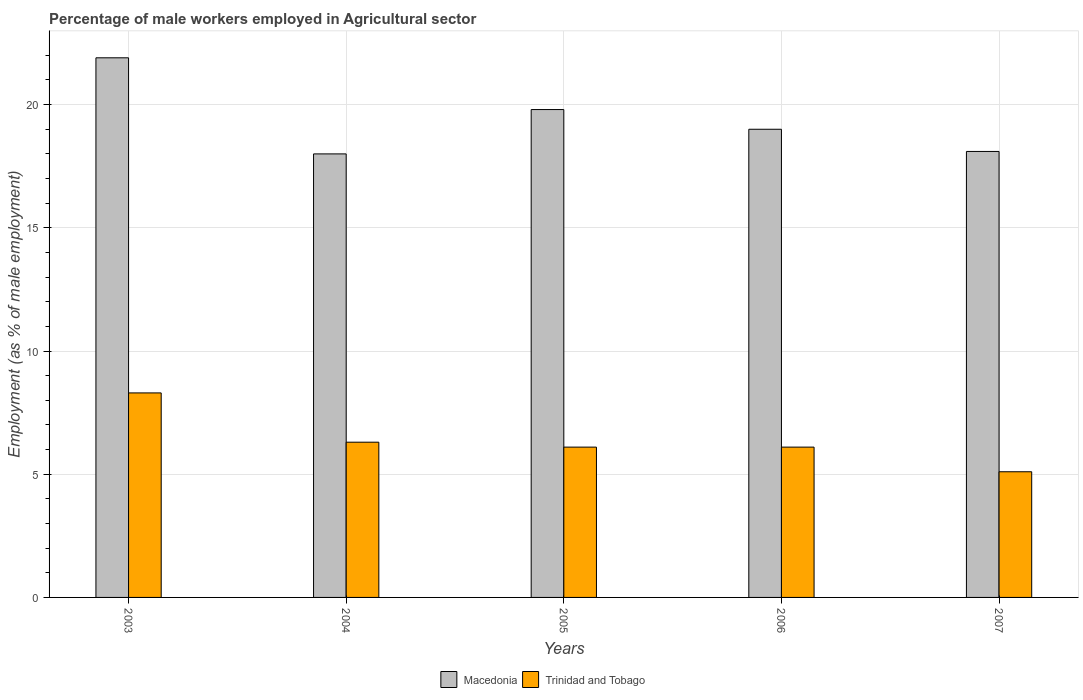How many groups of bars are there?
Your response must be concise. 5. Are the number of bars on each tick of the X-axis equal?
Your answer should be very brief. Yes. In how many cases, is the number of bars for a given year not equal to the number of legend labels?
Offer a very short reply. 0. What is the percentage of male workers employed in Agricultural sector in Macedonia in 2005?
Provide a short and direct response. 19.8. Across all years, what is the maximum percentage of male workers employed in Agricultural sector in Trinidad and Tobago?
Give a very brief answer. 8.3. Across all years, what is the minimum percentage of male workers employed in Agricultural sector in Trinidad and Tobago?
Provide a short and direct response. 5.1. In which year was the percentage of male workers employed in Agricultural sector in Macedonia maximum?
Your response must be concise. 2003. What is the total percentage of male workers employed in Agricultural sector in Trinidad and Tobago in the graph?
Your response must be concise. 31.9. What is the difference between the percentage of male workers employed in Agricultural sector in Trinidad and Tobago in 2003 and that in 2006?
Give a very brief answer. 2.2. What is the difference between the percentage of male workers employed in Agricultural sector in Trinidad and Tobago in 2005 and the percentage of male workers employed in Agricultural sector in Macedonia in 2004?
Your answer should be very brief. -11.9. What is the average percentage of male workers employed in Agricultural sector in Trinidad and Tobago per year?
Ensure brevity in your answer.  6.38. In the year 2005, what is the difference between the percentage of male workers employed in Agricultural sector in Macedonia and percentage of male workers employed in Agricultural sector in Trinidad and Tobago?
Provide a short and direct response. 13.7. What is the ratio of the percentage of male workers employed in Agricultural sector in Trinidad and Tobago in 2004 to that in 2007?
Your answer should be very brief. 1.24. What is the difference between the highest and the second highest percentage of male workers employed in Agricultural sector in Trinidad and Tobago?
Provide a succinct answer. 2. What is the difference between the highest and the lowest percentage of male workers employed in Agricultural sector in Macedonia?
Ensure brevity in your answer.  3.9. In how many years, is the percentage of male workers employed in Agricultural sector in Macedonia greater than the average percentage of male workers employed in Agricultural sector in Macedonia taken over all years?
Ensure brevity in your answer.  2. Is the sum of the percentage of male workers employed in Agricultural sector in Macedonia in 2003 and 2005 greater than the maximum percentage of male workers employed in Agricultural sector in Trinidad and Tobago across all years?
Your answer should be compact. Yes. What does the 1st bar from the left in 2006 represents?
Offer a terse response. Macedonia. What does the 2nd bar from the right in 2006 represents?
Give a very brief answer. Macedonia. Are all the bars in the graph horizontal?
Provide a short and direct response. No. What is the difference between two consecutive major ticks on the Y-axis?
Your response must be concise. 5. Are the values on the major ticks of Y-axis written in scientific E-notation?
Offer a terse response. No. Does the graph contain grids?
Offer a very short reply. Yes. What is the title of the graph?
Your answer should be very brief. Percentage of male workers employed in Agricultural sector. What is the label or title of the X-axis?
Your response must be concise. Years. What is the label or title of the Y-axis?
Your answer should be very brief. Employment (as % of male employment). What is the Employment (as % of male employment) in Macedonia in 2003?
Offer a very short reply. 21.9. What is the Employment (as % of male employment) of Trinidad and Tobago in 2003?
Provide a short and direct response. 8.3. What is the Employment (as % of male employment) in Trinidad and Tobago in 2004?
Your answer should be compact. 6.3. What is the Employment (as % of male employment) of Macedonia in 2005?
Offer a terse response. 19.8. What is the Employment (as % of male employment) of Trinidad and Tobago in 2005?
Offer a very short reply. 6.1. What is the Employment (as % of male employment) of Macedonia in 2006?
Ensure brevity in your answer.  19. What is the Employment (as % of male employment) of Trinidad and Tobago in 2006?
Give a very brief answer. 6.1. What is the Employment (as % of male employment) of Macedonia in 2007?
Your answer should be very brief. 18.1. What is the Employment (as % of male employment) in Trinidad and Tobago in 2007?
Offer a very short reply. 5.1. Across all years, what is the maximum Employment (as % of male employment) of Macedonia?
Offer a terse response. 21.9. Across all years, what is the maximum Employment (as % of male employment) in Trinidad and Tobago?
Make the answer very short. 8.3. Across all years, what is the minimum Employment (as % of male employment) of Trinidad and Tobago?
Your answer should be compact. 5.1. What is the total Employment (as % of male employment) in Macedonia in the graph?
Give a very brief answer. 96.8. What is the total Employment (as % of male employment) in Trinidad and Tobago in the graph?
Provide a short and direct response. 31.9. What is the difference between the Employment (as % of male employment) in Macedonia in 2003 and that in 2004?
Ensure brevity in your answer.  3.9. What is the difference between the Employment (as % of male employment) of Trinidad and Tobago in 2003 and that in 2004?
Your answer should be compact. 2. What is the difference between the Employment (as % of male employment) of Trinidad and Tobago in 2003 and that in 2005?
Offer a terse response. 2.2. What is the difference between the Employment (as % of male employment) of Trinidad and Tobago in 2003 and that in 2006?
Your answer should be very brief. 2.2. What is the difference between the Employment (as % of male employment) in Macedonia in 2004 and that in 2006?
Offer a terse response. -1. What is the difference between the Employment (as % of male employment) in Trinidad and Tobago in 2004 and that in 2006?
Provide a succinct answer. 0.2. What is the difference between the Employment (as % of male employment) in Trinidad and Tobago in 2004 and that in 2007?
Offer a very short reply. 1.2. What is the difference between the Employment (as % of male employment) in Trinidad and Tobago in 2005 and that in 2007?
Your answer should be compact. 1. What is the difference between the Employment (as % of male employment) of Macedonia in 2006 and that in 2007?
Ensure brevity in your answer.  0.9. What is the difference between the Employment (as % of male employment) of Trinidad and Tobago in 2006 and that in 2007?
Your answer should be very brief. 1. What is the difference between the Employment (as % of male employment) of Macedonia in 2003 and the Employment (as % of male employment) of Trinidad and Tobago in 2006?
Provide a succinct answer. 15.8. What is the difference between the Employment (as % of male employment) of Macedonia in 2004 and the Employment (as % of male employment) of Trinidad and Tobago in 2007?
Offer a terse response. 12.9. What is the difference between the Employment (as % of male employment) in Macedonia in 2005 and the Employment (as % of male employment) in Trinidad and Tobago in 2006?
Provide a short and direct response. 13.7. What is the difference between the Employment (as % of male employment) in Macedonia in 2005 and the Employment (as % of male employment) in Trinidad and Tobago in 2007?
Ensure brevity in your answer.  14.7. What is the difference between the Employment (as % of male employment) of Macedonia in 2006 and the Employment (as % of male employment) of Trinidad and Tobago in 2007?
Ensure brevity in your answer.  13.9. What is the average Employment (as % of male employment) of Macedonia per year?
Your answer should be very brief. 19.36. What is the average Employment (as % of male employment) of Trinidad and Tobago per year?
Your answer should be very brief. 6.38. In the year 2003, what is the difference between the Employment (as % of male employment) of Macedonia and Employment (as % of male employment) of Trinidad and Tobago?
Ensure brevity in your answer.  13.6. In the year 2004, what is the difference between the Employment (as % of male employment) in Macedonia and Employment (as % of male employment) in Trinidad and Tobago?
Your answer should be compact. 11.7. In the year 2005, what is the difference between the Employment (as % of male employment) in Macedonia and Employment (as % of male employment) in Trinidad and Tobago?
Your answer should be very brief. 13.7. In the year 2006, what is the difference between the Employment (as % of male employment) of Macedonia and Employment (as % of male employment) of Trinidad and Tobago?
Provide a succinct answer. 12.9. What is the ratio of the Employment (as % of male employment) of Macedonia in 2003 to that in 2004?
Offer a terse response. 1.22. What is the ratio of the Employment (as % of male employment) in Trinidad and Tobago in 2003 to that in 2004?
Ensure brevity in your answer.  1.32. What is the ratio of the Employment (as % of male employment) of Macedonia in 2003 to that in 2005?
Offer a terse response. 1.11. What is the ratio of the Employment (as % of male employment) in Trinidad and Tobago in 2003 to that in 2005?
Offer a terse response. 1.36. What is the ratio of the Employment (as % of male employment) in Macedonia in 2003 to that in 2006?
Give a very brief answer. 1.15. What is the ratio of the Employment (as % of male employment) of Trinidad and Tobago in 2003 to that in 2006?
Your answer should be very brief. 1.36. What is the ratio of the Employment (as % of male employment) in Macedonia in 2003 to that in 2007?
Your answer should be compact. 1.21. What is the ratio of the Employment (as % of male employment) of Trinidad and Tobago in 2003 to that in 2007?
Make the answer very short. 1.63. What is the ratio of the Employment (as % of male employment) of Macedonia in 2004 to that in 2005?
Your answer should be very brief. 0.91. What is the ratio of the Employment (as % of male employment) in Trinidad and Tobago in 2004 to that in 2005?
Give a very brief answer. 1.03. What is the ratio of the Employment (as % of male employment) in Macedonia in 2004 to that in 2006?
Your answer should be compact. 0.95. What is the ratio of the Employment (as % of male employment) of Trinidad and Tobago in 2004 to that in 2006?
Ensure brevity in your answer.  1.03. What is the ratio of the Employment (as % of male employment) of Trinidad and Tobago in 2004 to that in 2007?
Provide a succinct answer. 1.24. What is the ratio of the Employment (as % of male employment) in Macedonia in 2005 to that in 2006?
Provide a succinct answer. 1.04. What is the ratio of the Employment (as % of male employment) of Macedonia in 2005 to that in 2007?
Your response must be concise. 1.09. What is the ratio of the Employment (as % of male employment) in Trinidad and Tobago in 2005 to that in 2007?
Your answer should be very brief. 1.2. What is the ratio of the Employment (as % of male employment) in Macedonia in 2006 to that in 2007?
Offer a very short reply. 1.05. What is the ratio of the Employment (as % of male employment) in Trinidad and Tobago in 2006 to that in 2007?
Give a very brief answer. 1.2. What is the difference between the highest and the second highest Employment (as % of male employment) of Macedonia?
Your answer should be compact. 2.1. What is the difference between the highest and the lowest Employment (as % of male employment) in Macedonia?
Your answer should be compact. 3.9. 